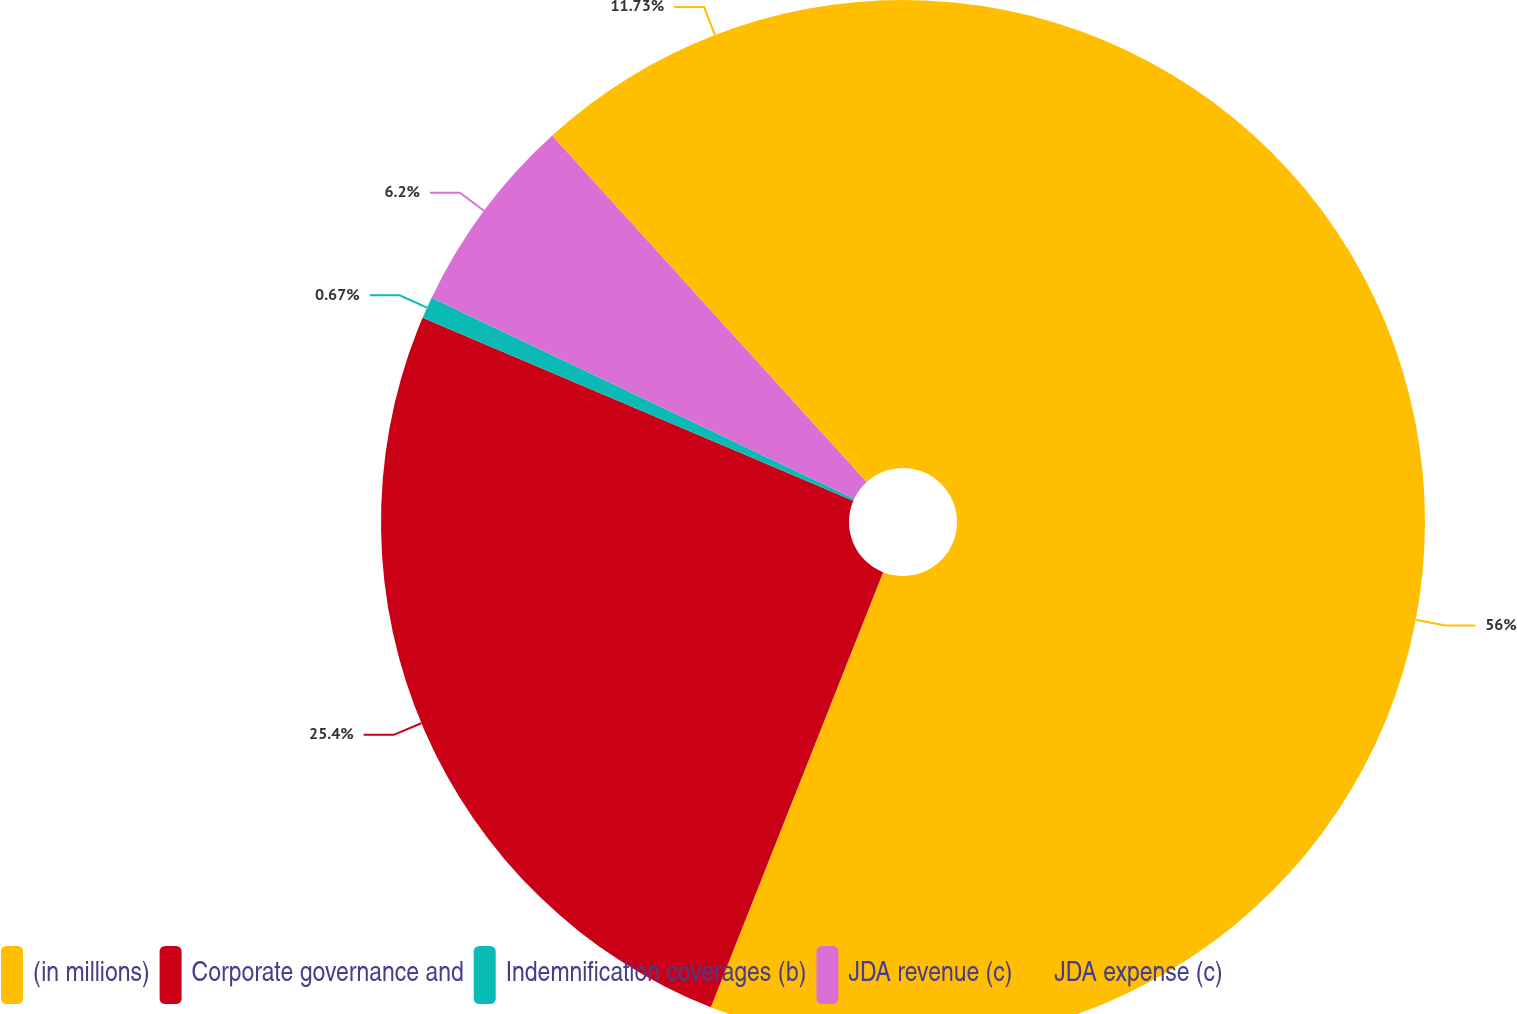<chart> <loc_0><loc_0><loc_500><loc_500><pie_chart><fcel>(in millions)<fcel>Corporate governance and<fcel>Indemnification coverages (b)<fcel>JDA revenue (c)<fcel>JDA expense (c)<nl><fcel>56.0%<fcel>25.4%<fcel>0.67%<fcel>6.2%<fcel>11.73%<nl></chart> 